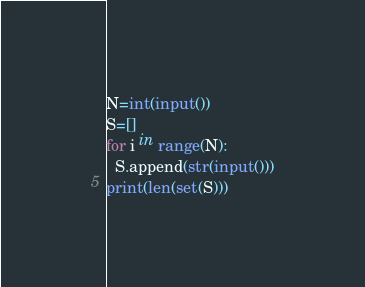Convert code to text. <code><loc_0><loc_0><loc_500><loc_500><_Python_>N=int(input())
S=[]
for i in range(N):
  S.append(str(input()))
print(len(set(S)))</code> 